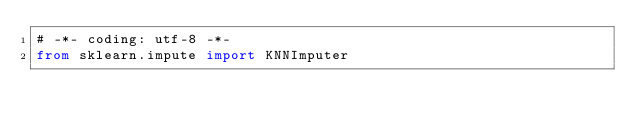<code> <loc_0><loc_0><loc_500><loc_500><_Python_># -*- coding: utf-8 -*-
from sklearn.impute import KNNImputer</code> 